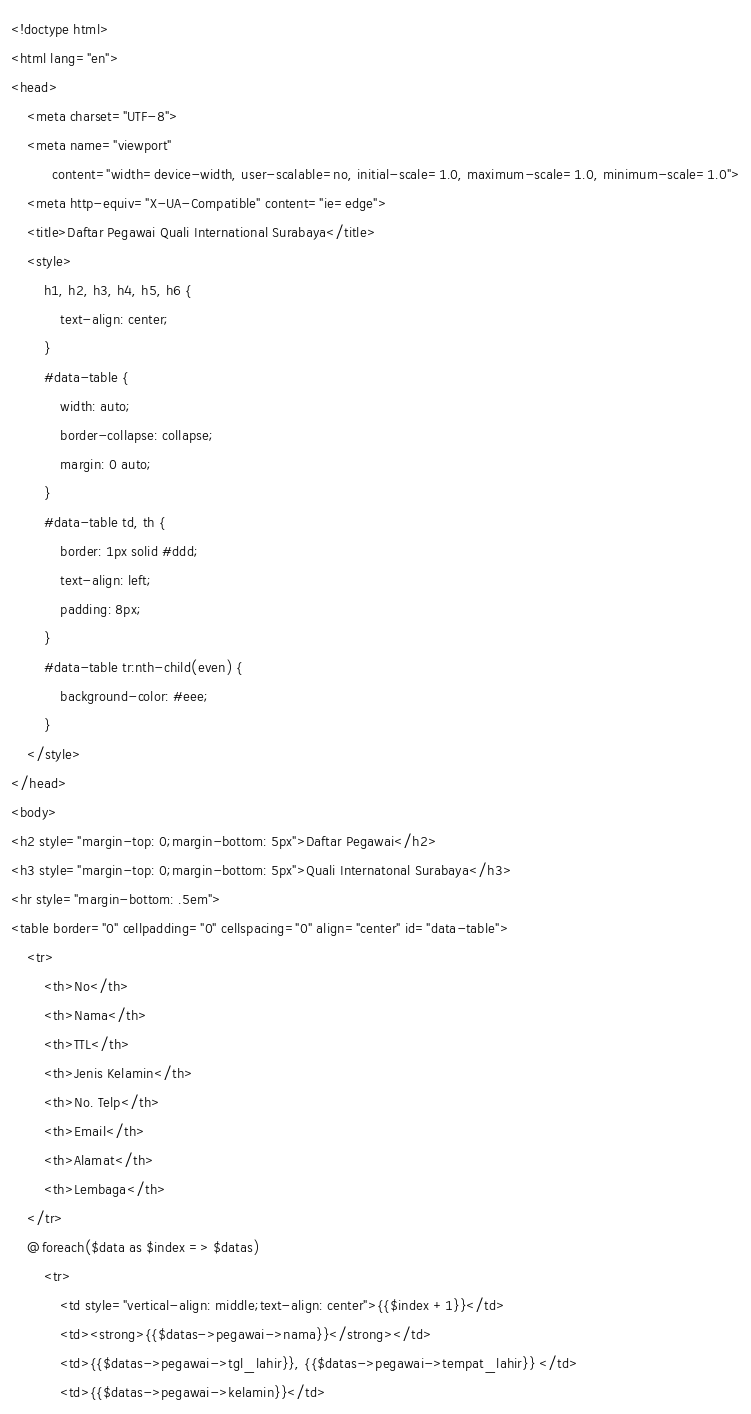<code> <loc_0><loc_0><loc_500><loc_500><_PHP_><!doctype html>
<html lang="en">
<head>
    <meta charset="UTF-8">
    <meta name="viewport"
          content="width=device-width, user-scalable=no, initial-scale=1.0, maximum-scale=1.0, minimum-scale=1.0">
    <meta http-equiv="X-UA-Compatible" content="ie=edge">
    <title>Daftar Pegawai Quali International Surabaya</title>
    <style>
        h1, h2, h3, h4, h5, h6 {
            text-align: center;
        }
        #data-table {
            width: auto;
            border-collapse: collapse;
            margin: 0 auto;
        }
        #data-table td, th {
            border: 1px solid #ddd;
            text-align: left;
            padding: 8px;
        }
        #data-table tr:nth-child(even) {
            background-color: #eee;
        }
    </style>
</head>
<body>
<h2 style="margin-top: 0;margin-bottom: 5px">Daftar Pegawai</h2>
<h3 style="margin-top: 0;margin-bottom: 5px">Quali Internatonal Surabaya</h3>
<hr style="margin-bottom: .5em">
<table border="0" cellpadding="0" cellspacing="0" align="center" id="data-table">
    <tr>
        <th>No</th>
        <th>Nama</th>
        <th>TTL</th>
        <th>Jenis Kelamin</th>
        <th>No. Telp</th>
        <th>Email</th>
        <th>Alamat</th>
        <th>Lembaga</th>
    </tr>
    @foreach($data as $index => $datas)
        <tr>
            <td style="vertical-align: middle;text-align: center">{{$index +1}}</td>
            <td><strong>{{$datas->pegawai->nama}}</strong></td>
            <td>{{$datas->pegawai->tgl_lahir}}, {{$datas->pegawai->tempat_lahir}} </td>
            <td>{{$datas->pegawai->kelamin}}</td></code> 